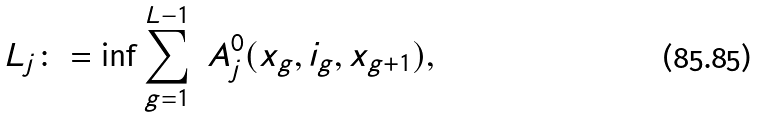<formula> <loc_0><loc_0><loc_500><loc_500>L _ { j } \colon = \inf \sum _ { g = 1 } ^ { L - 1 } \ A ^ { 0 } _ { j } ( x _ { g } , i _ { g } , x _ { g + 1 } ) ,</formula> 